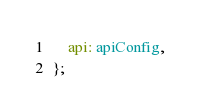Convert code to text. <code><loc_0><loc_0><loc_500><loc_500><_TypeScript_>
	api: apiConfig,
};
</code> 